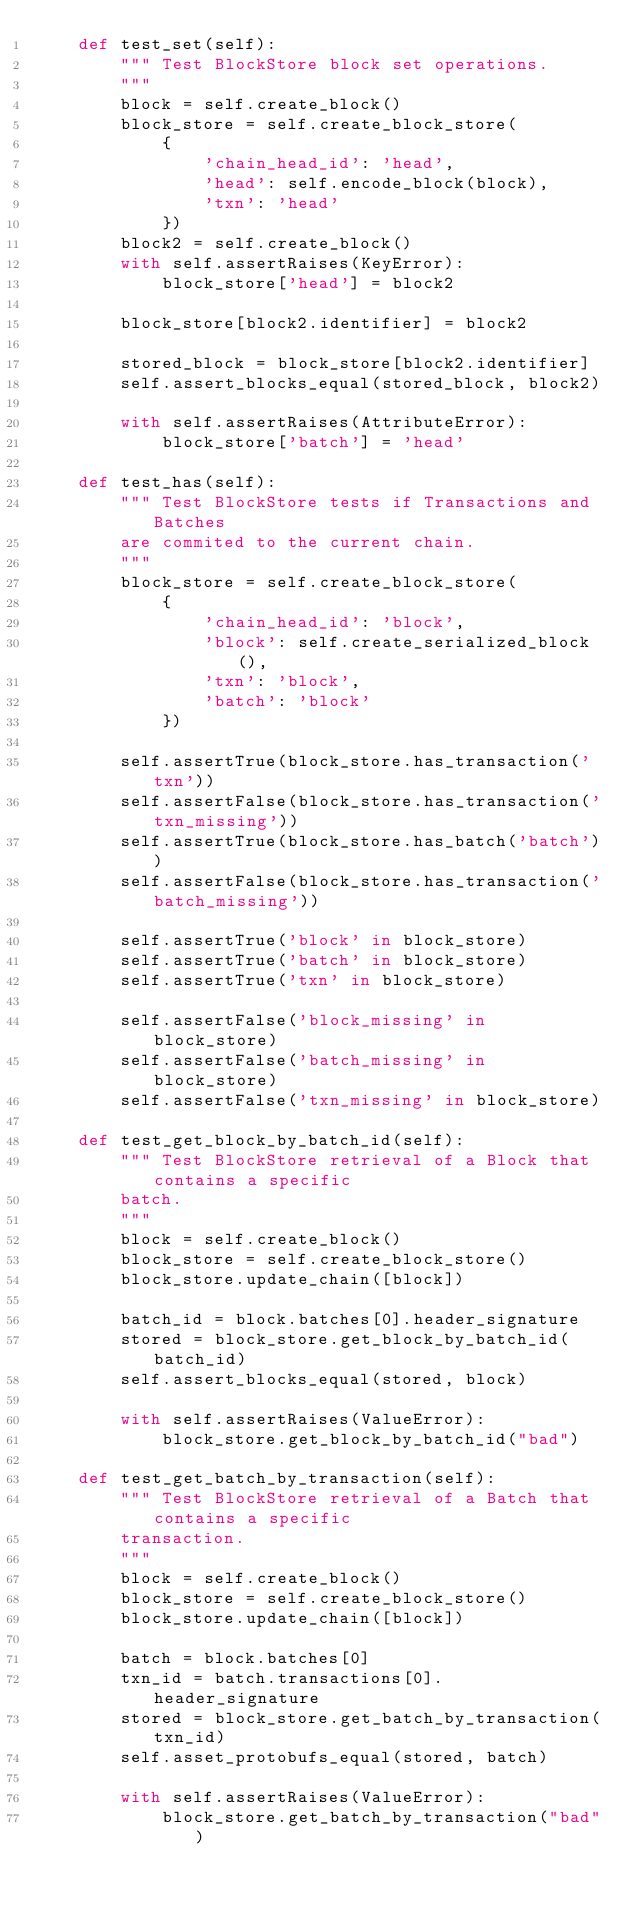Convert code to text. <code><loc_0><loc_0><loc_500><loc_500><_Python_>    def test_set(self):
        """ Test BlockStore block set operations.
        """
        block = self.create_block()
        block_store = self.create_block_store(
            {
                'chain_head_id': 'head',
                'head': self.encode_block(block),
                'txn': 'head'
            })
        block2 = self.create_block()
        with self.assertRaises(KeyError):
            block_store['head'] = block2

        block_store[block2.identifier] = block2

        stored_block = block_store[block2.identifier]
        self.assert_blocks_equal(stored_block, block2)

        with self.assertRaises(AttributeError):
            block_store['batch'] = 'head'

    def test_has(self):
        """ Test BlockStore tests if Transactions and Batches
        are commited to the current chain.
        """
        block_store = self.create_block_store(
            {
                'chain_head_id': 'block',
                'block': self.create_serialized_block(),
                'txn': 'block',
                'batch': 'block'
            })

        self.assertTrue(block_store.has_transaction('txn'))
        self.assertFalse(block_store.has_transaction('txn_missing'))
        self.assertTrue(block_store.has_batch('batch'))
        self.assertFalse(block_store.has_transaction('batch_missing'))

        self.assertTrue('block' in block_store)
        self.assertTrue('batch' in block_store)
        self.assertTrue('txn' in block_store)

        self.assertFalse('block_missing' in block_store)
        self.assertFalse('batch_missing' in block_store)
        self.assertFalse('txn_missing' in block_store)

    def test_get_block_by_batch_id(self):
        """ Test BlockStore retrieval of a Block that contains a specific
        batch.
        """
        block = self.create_block()
        block_store = self.create_block_store()
        block_store.update_chain([block])

        batch_id = block.batches[0].header_signature
        stored = block_store.get_block_by_batch_id(batch_id)
        self.assert_blocks_equal(stored, block)

        with self.assertRaises(ValueError):
            block_store.get_block_by_batch_id("bad")

    def test_get_batch_by_transaction(self):
        """ Test BlockStore retrieval of a Batch that contains a specific
        transaction.
        """
        block = self.create_block()
        block_store = self.create_block_store()
        block_store.update_chain([block])

        batch = block.batches[0]
        txn_id = batch.transactions[0].header_signature
        stored = block_store.get_batch_by_transaction(txn_id)
        self.asset_protobufs_equal(stored, batch)

        with self.assertRaises(ValueError):
            block_store.get_batch_by_transaction("bad")
</code> 